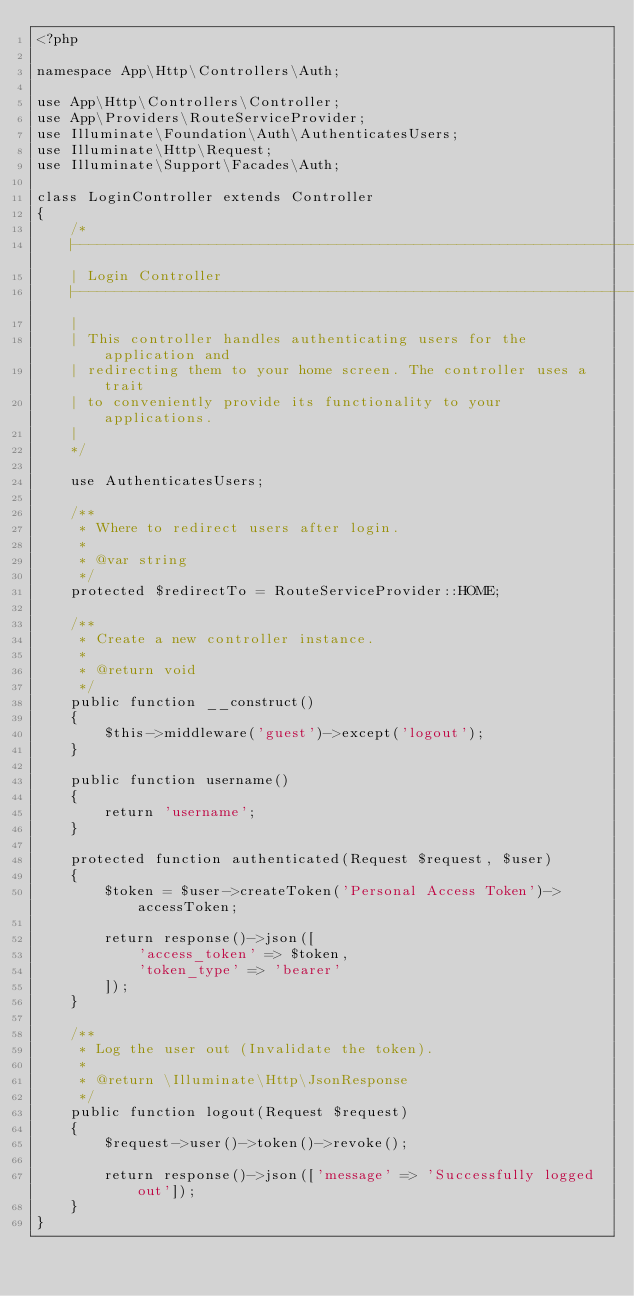Convert code to text. <code><loc_0><loc_0><loc_500><loc_500><_PHP_><?php

namespace App\Http\Controllers\Auth;

use App\Http\Controllers\Controller;
use App\Providers\RouteServiceProvider;
use Illuminate\Foundation\Auth\AuthenticatesUsers;
use Illuminate\Http\Request;
use Illuminate\Support\Facades\Auth;

class LoginController extends Controller
{
    /*
    |--------------------------------------------------------------------------
    | Login Controller
    |--------------------------------------------------------------------------
    |
    | This controller handles authenticating users for the application and
    | redirecting them to your home screen. The controller uses a trait
    | to conveniently provide its functionality to your applications.
    |
    */

    use AuthenticatesUsers;

    /**
     * Where to redirect users after login.
     *
     * @var string
     */
    protected $redirectTo = RouteServiceProvider::HOME;

    /**
     * Create a new controller instance.
     *
     * @return void
     */
    public function __construct()
    {
        $this->middleware('guest')->except('logout');
    }

    public function username()
    {
        return 'username';
    }

    protected function authenticated(Request $request, $user)
    {
        $token = $user->createToken('Personal Access Token')->accessToken;

        return response()->json([
            'access_token' => $token,
            'token_type' => 'bearer'
        ]);
    }

    /**
     * Log the user out (Invalidate the token).
     *
     * @return \Illuminate\Http\JsonResponse
     */
    public function logout(Request $request)
    {
        $request->user()->token()->revoke();

        return response()->json(['message' => 'Successfully logged out']);
    }
}
</code> 